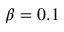<formula> <loc_0><loc_0><loc_500><loc_500>\beta = 0 . 1</formula> 